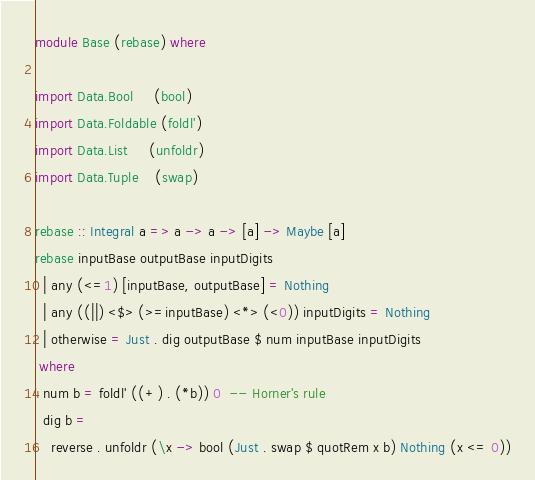Convert code to text. <code><loc_0><loc_0><loc_500><loc_500><_Haskell_>module Base (rebase) where

import Data.Bool     (bool)
import Data.Foldable (foldl')
import Data.List     (unfoldr)
import Data.Tuple    (swap)

rebase :: Integral a => a -> a -> [a] -> Maybe [a]
rebase inputBase outputBase inputDigits
  | any (<=1) [inputBase, outputBase] = Nothing
  | any ((||) <$> (>=inputBase) <*> (<0)) inputDigits = Nothing
  | otherwise = Just . dig outputBase $ num inputBase inputDigits
 where
  num b = foldl' ((+) . (*b)) 0  -- Horner's rule
  dig b =
    reverse . unfoldr (\x -> bool (Just . swap $ quotRem x b) Nothing (x <= 0))
</code> 